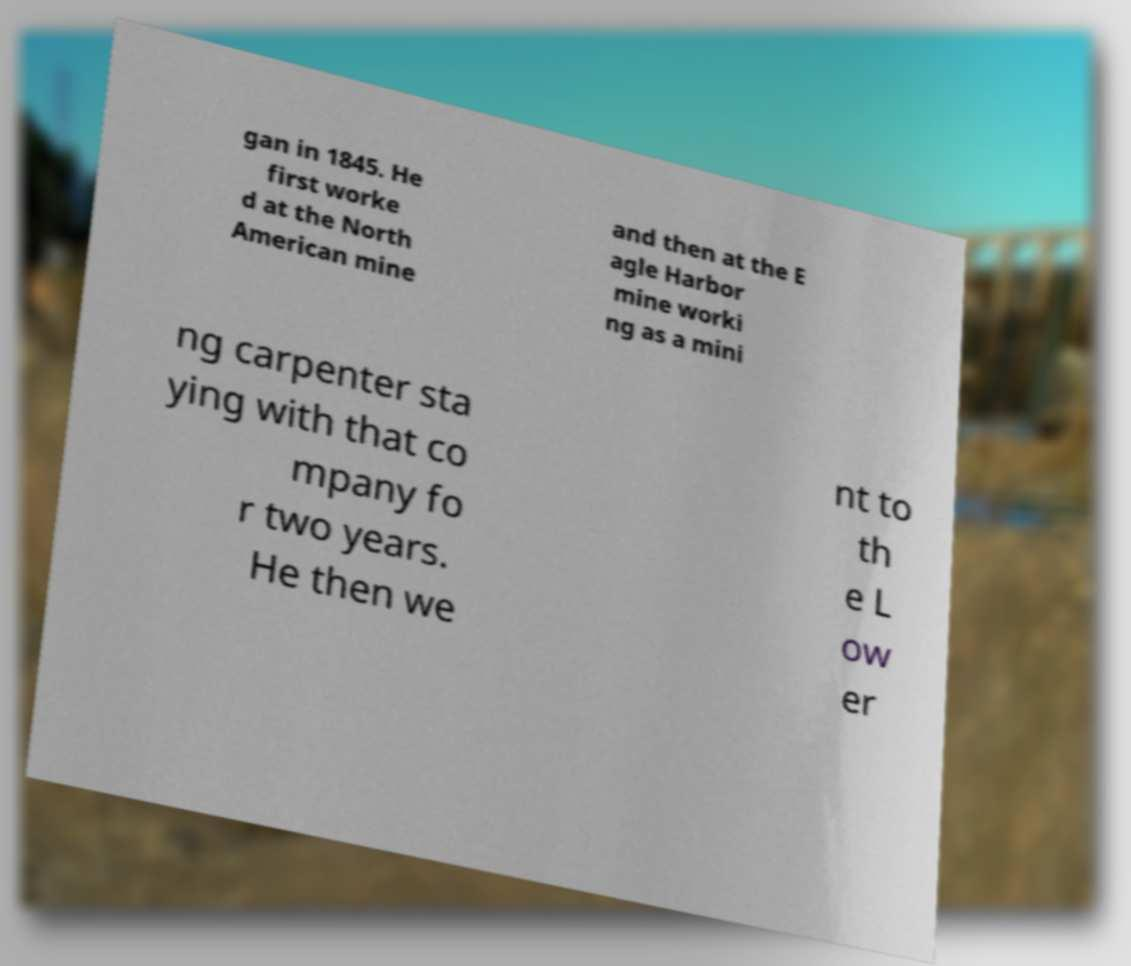Can you accurately transcribe the text from the provided image for me? gan in 1845. He first worke d at the North American mine and then at the E agle Harbor mine worki ng as a mini ng carpenter sta ying with that co mpany fo r two years. He then we nt to th e L ow er 